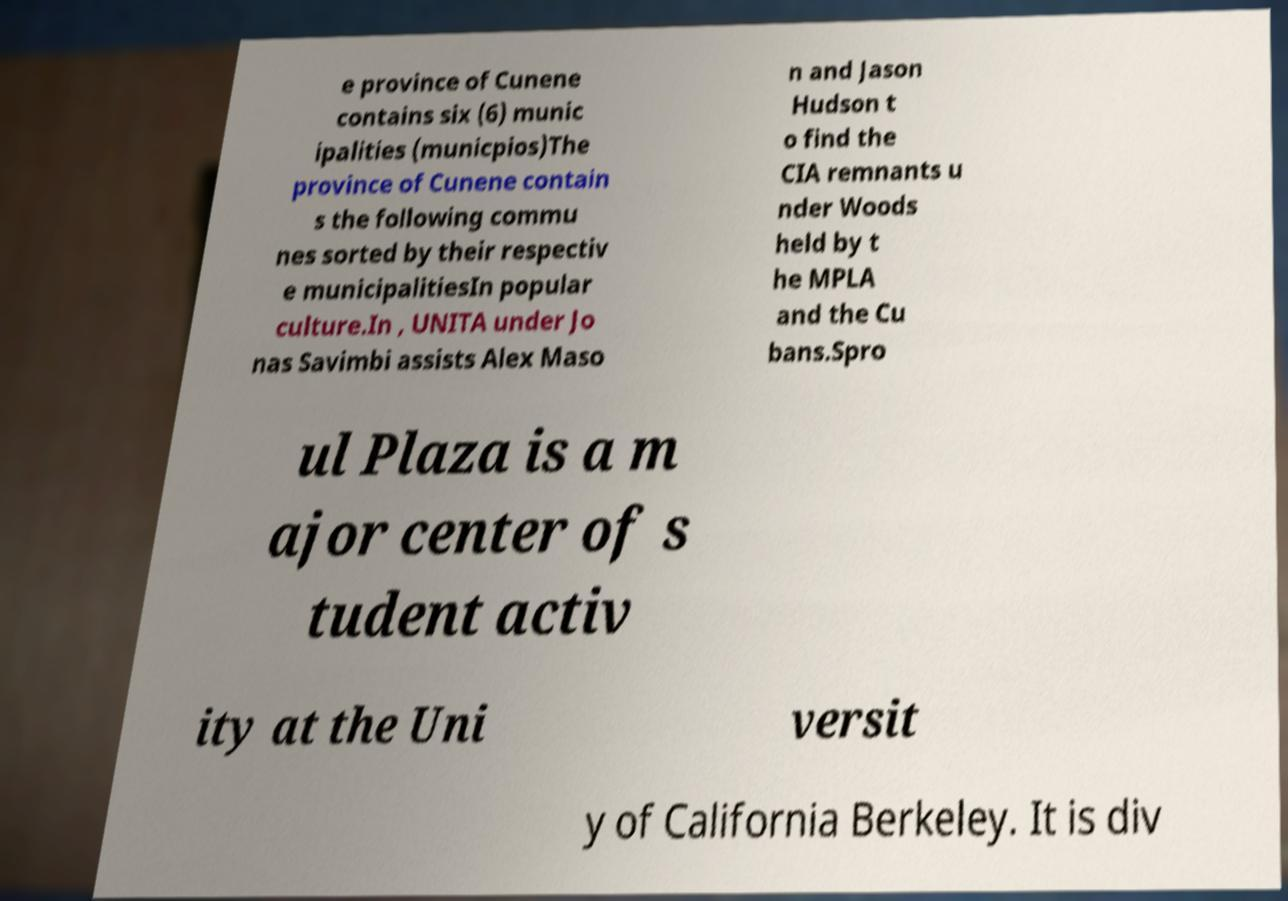What messages or text are displayed in this image? I need them in a readable, typed format. e province of Cunene contains six (6) munic ipalities (municpios)The province of Cunene contain s the following commu nes sorted by their respectiv e municipalitiesIn popular culture.In , UNITA under Jo nas Savimbi assists Alex Maso n and Jason Hudson t o find the CIA remnants u nder Woods held by t he MPLA and the Cu bans.Spro ul Plaza is a m ajor center of s tudent activ ity at the Uni versit y of California Berkeley. It is div 